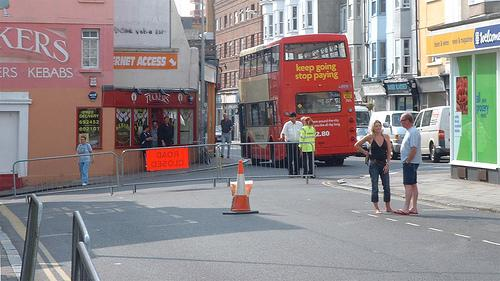Where are these 2 people standing? Please explain your reasoning. street. The two people closest to the foreground are standing on a paved surface with traffic lines painted on the ground and vehicles in the background. this elements are consistent with answer a. 